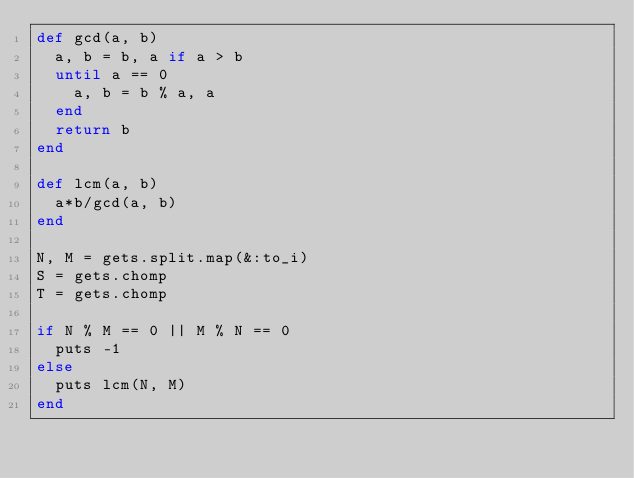Convert code to text. <code><loc_0><loc_0><loc_500><loc_500><_Ruby_>def gcd(a, b)
  a, b = b, a if a > b
  until a == 0
    a, b = b % a, a
  end
  return b
end

def lcm(a, b)
  a*b/gcd(a, b)
end

N, M = gets.split.map(&:to_i)
S = gets.chomp
T = gets.chomp

if N % M == 0 || M % N == 0
  puts -1
else
  puts lcm(N, M)
end
</code> 